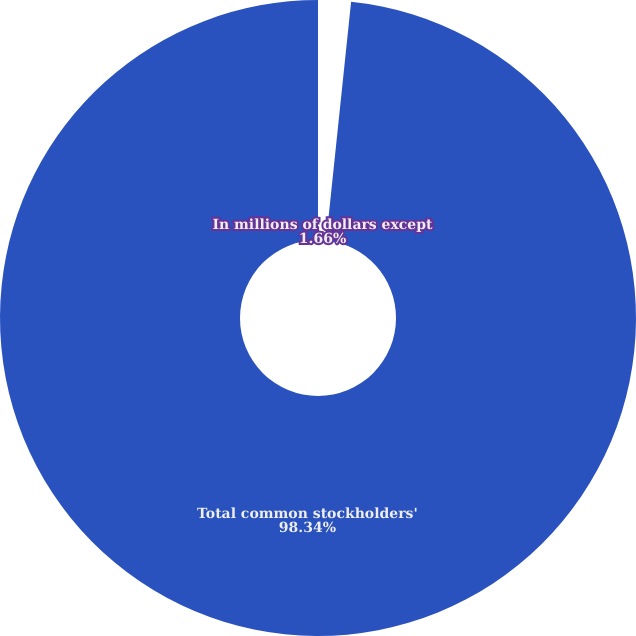Convert chart to OTSL. <chart><loc_0><loc_0><loc_500><loc_500><pie_chart><fcel>In millions of dollars except<fcel>Total common stockholders'<nl><fcel>1.66%<fcel>98.34%<nl></chart> 